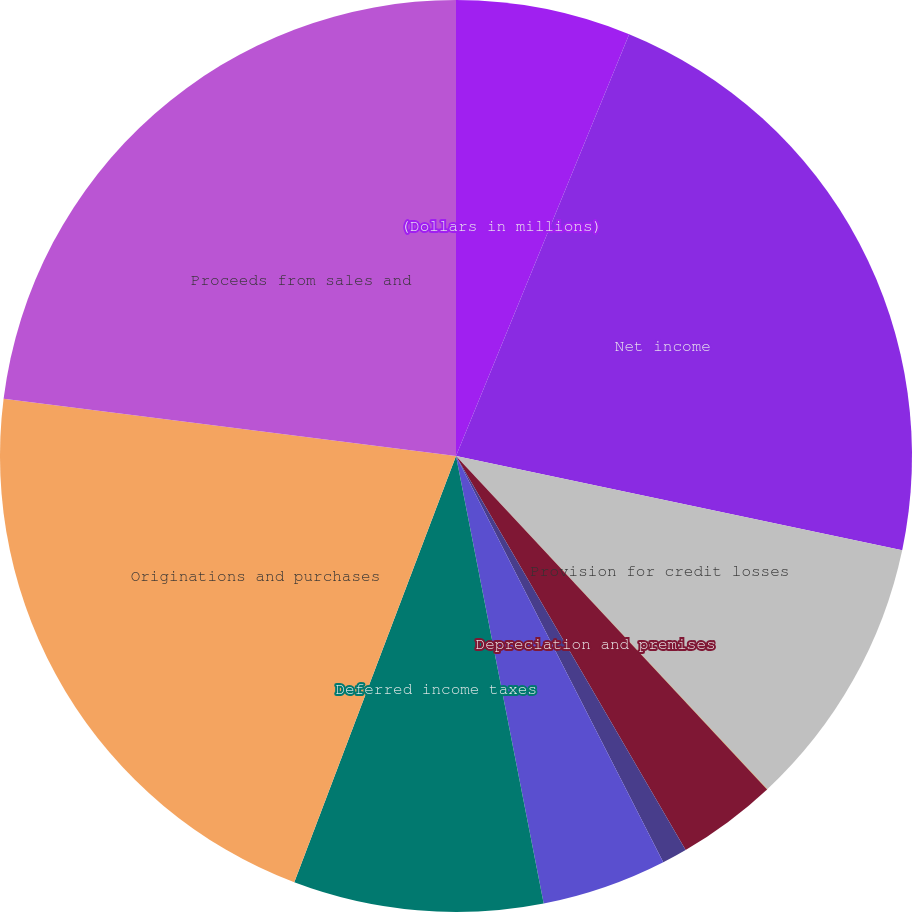Convert chart. <chart><loc_0><loc_0><loc_500><loc_500><pie_chart><fcel>(Dollars in millions)<fcel>Net income<fcel>Provision for credit losses<fcel>Gains on sales of debt<fcel>Depreciation and premises<fcel>Amortization of intangibles<fcel>Net amortization of<fcel>Deferred income taxes<fcel>Originations and purchases<fcel>Proceeds from sales and<nl><fcel>6.2%<fcel>22.11%<fcel>9.73%<fcel>0.01%<fcel>3.55%<fcel>0.89%<fcel>4.43%<fcel>8.85%<fcel>21.23%<fcel>23.0%<nl></chart> 